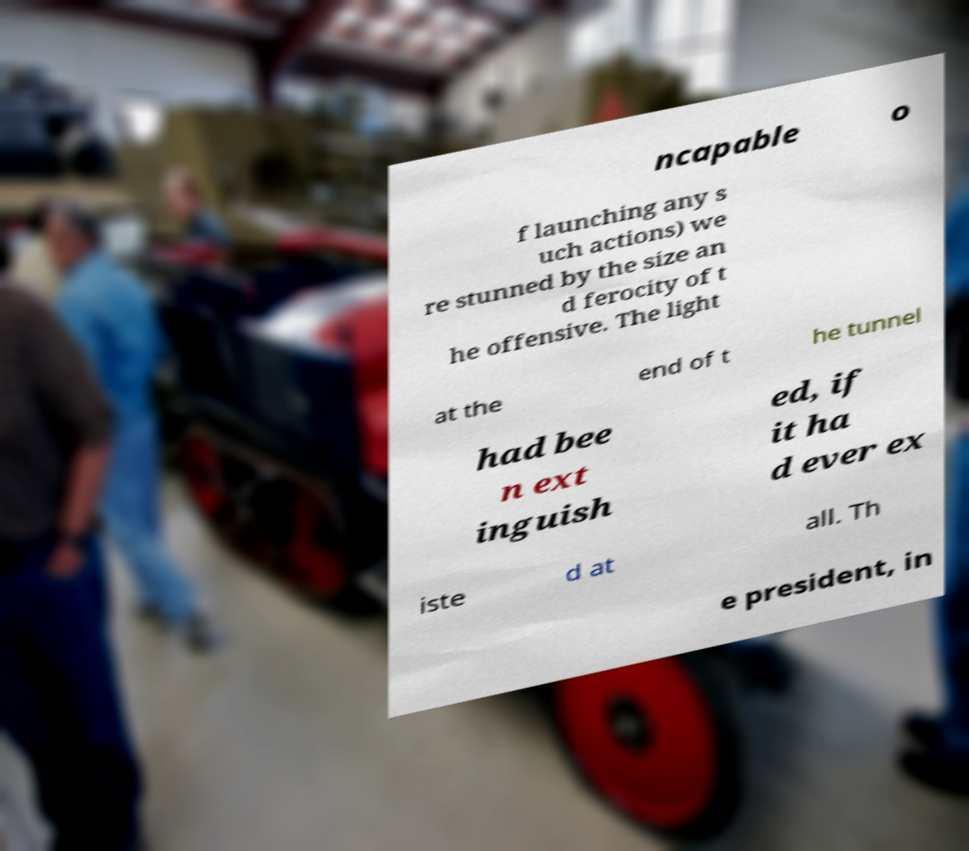Can you accurately transcribe the text from the provided image for me? ncapable o f launching any s uch actions) we re stunned by the size an d ferocity of t he offensive. The light at the end of t he tunnel had bee n ext inguish ed, if it ha d ever ex iste d at all. Th e president, in 